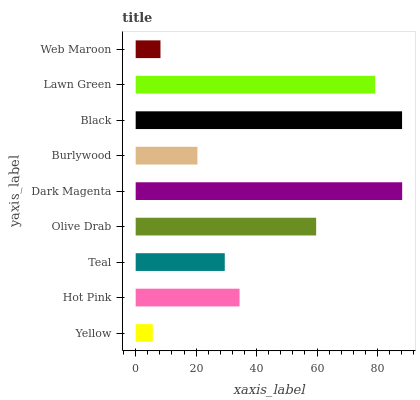Is Yellow the minimum?
Answer yes or no. Yes. Is Dark Magenta the maximum?
Answer yes or no. Yes. Is Hot Pink the minimum?
Answer yes or no. No. Is Hot Pink the maximum?
Answer yes or no. No. Is Hot Pink greater than Yellow?
Answer yes or no. Yes. Is Yellow less than Hot Pink?
Answer yes or no. Yes. Is Yellow greater than Hot Pink?
Answer yes or no. No. Is Hot Pink less than Yellow?
Answer yes or no. No. Is Hot Pink the high median?
Answer yes or no. Yes. Is Hot Pink the low median?
Answer yes or no. Yes. Is Olive Drab the high median?
Answer yes or no. No. Is Dark Magenta the low median?
Answer yes or no. No. 